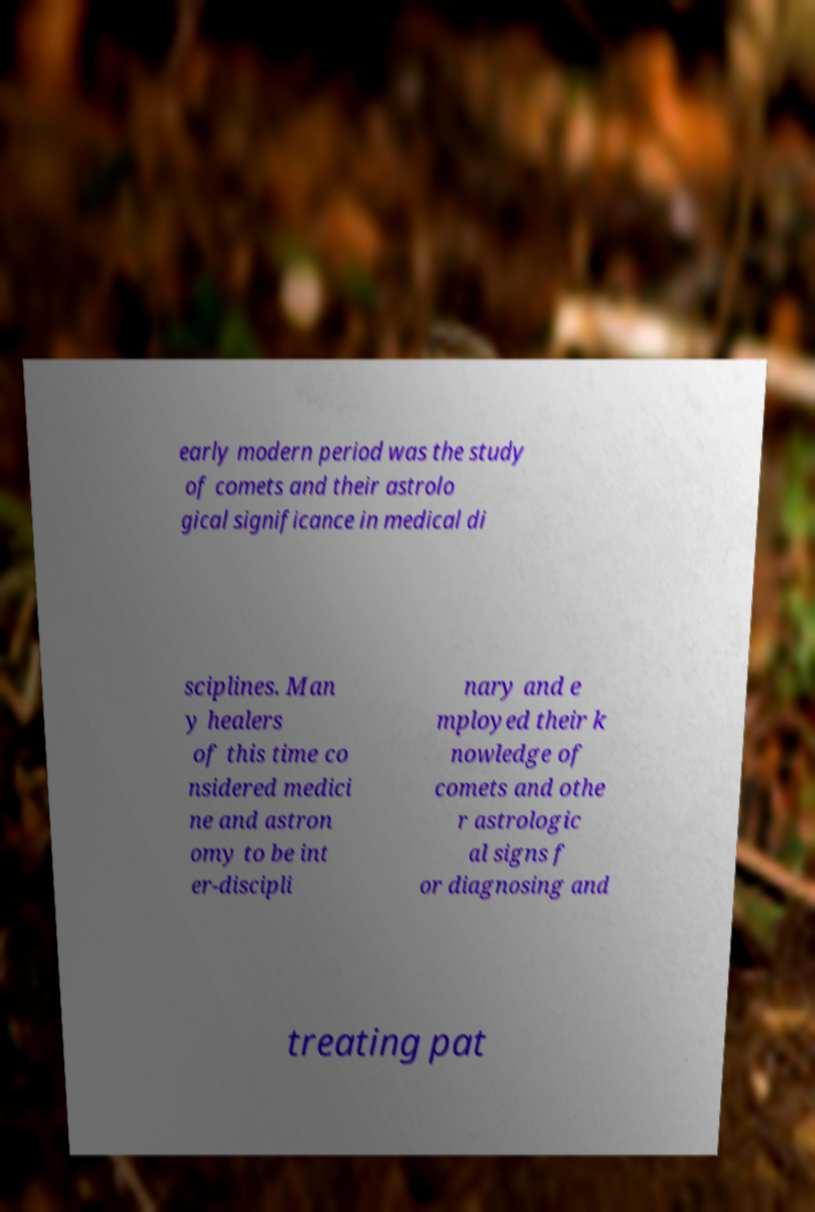There's text embedded in this image that I need extracted. Can you transcribe it verbatim? early modern period was the study of comets and their astrolo gical significance in medical di sciplines. Man y healers of this time co nsidered medici ne and astron omy to be int er-discipli nary and e mployed their k nowledge of comets and othe r astrologic al signs f or diagnosing and treating pat 